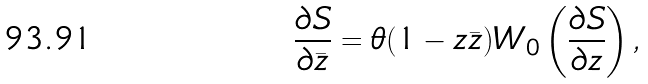Convert formula to latex. <formula><loc_0><loc_0><loc_500><loc_500>\frac { \partial S } { \partial \bar { z } } = \theta ( 1 - z \bar { z } ) W _ { 0 } \left ( \frac { \partial S } { \partial z } \right ) ,</formula> 